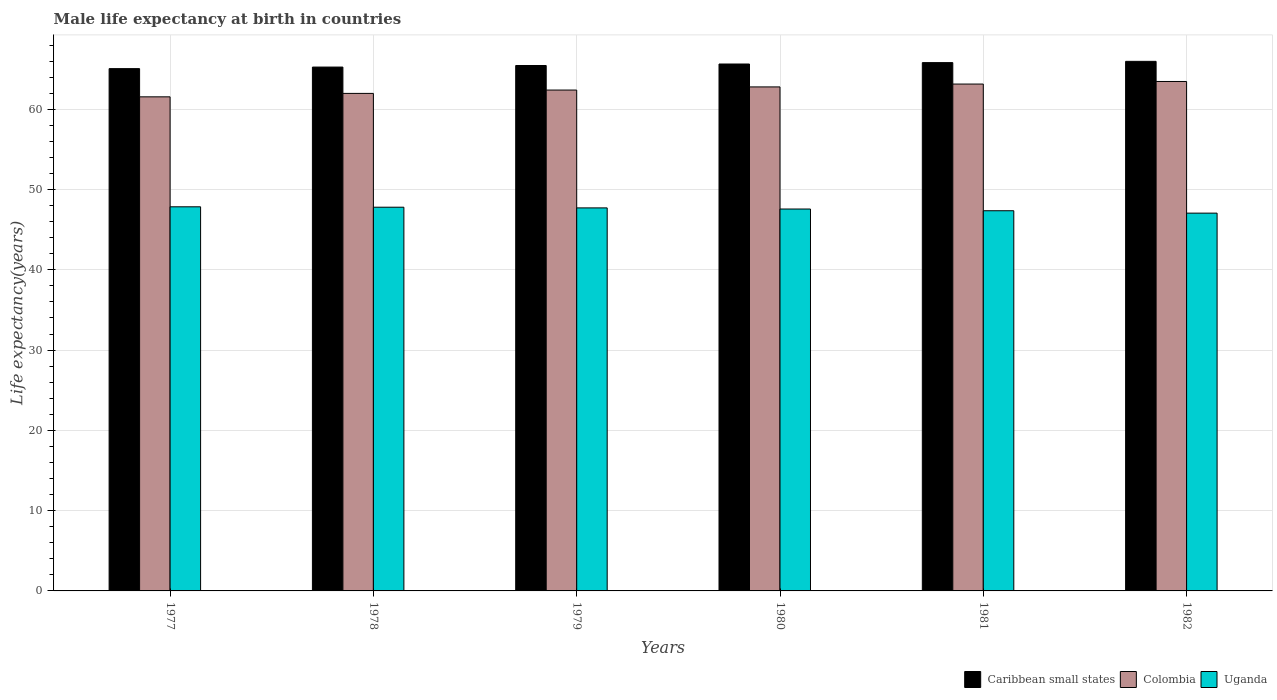How many groups of bars are there?
Provide a short and direct response. 6. Are the number of bars on each tick of the X-axis equal?
Your answer should be compact. Yes. How many bars are there on the 1st tick from the right?
Your response must be concise. 3. What is the label of the 1st group of bars from the left?
Make the answer very short. 1977. What is the male life expectancy at birth in Caribbean small states in 1979?
Offer a terse response. 65.45. Across all years, what is the maximum male life expectancy at birth in Uganda?
Provide a succinct answer. 47.85. Across all years, what is the minimum male life expectancy at birth in Uganda?
Provide a short and direct response. 47.06. In which year was the male life expectancy at birth in Colombia maximum?
Provide a succinct answer. 1982. What is the total male life expectancy at birth in Uganda in the graph?
Your answer should be compact. 285.36. What is the difference between the male life expectancy at birth in Uganda in 1978 and that in 1982?
Ensure brevity in your answer.  0.74. What is the difference between the male life expectancy at birth in Caribbean small states in 1977 and the male life expectancy at birth in Colombia in 1982?
Your response must be concise. 1.6. What is the average male life expectancy at birth in Colombia per year?
Ensure brevity in your answer.  62.55. In the year 1977, what is the difference between the male life expectancy at birth in Uganda and male life expectancy at birth in Caribbean small states?
Your answer should be compact. -17.21. What is the ratio of the male life expectancy at birth in Uganda in 1977 to that in 1980?
Give a very brief answer. 1.01. Is the difference between the male life expectancy at birth in Uganda in 1977 and 1981 greater than the difference between the male life expectancy at birth in Caribbean small states in 1977 and 1981?
Your answer should be very brief. Yes. What is the difference between the highest and the second highest male life expectancy at birth in Caribbean small states?
Your response must be concise. 0.16. What is the difference between the highest and the lowest male life expectancy at birth in Uganda?
Keep it short and to the point. 0.79. In how many years, is the male life expectancy at birth in Uganda greater than the average male life expectancy at birth in Uganda taken over all years?
Your answer should be compact. 4. Is the sum of the male life expectancy at birth in Caribbean small states in 1978 and 1982 greater than the maximum male life expectancy at birth in Uganda across all years?
Give a very brief answer. Yes. What does the 3rd bar from the left in 1982 represents?
Provide a succinct answer. Uganda. What does the 1st bar from the right in 1977 represents?
Offer a terse response. Uganda. How many bars are there?
Provide a succinct answer. 18. Are all the bars in the graph horizontal?
Your answer should be very brief. No. What is the difference between two consecutive major ticks on the Y-axis?
Make the answer very short. 10. Are the values on the major ticks of Y-axis written in scientific E-notation?
Give a very brief answer. No. How are the legend labels stacked?
Your response must be concise. Horizontal. What is the title of the graph?
Your answer should be very brief. Male life expectancy at birth in countries. Does "Serbia" appear as one of the legend labels in the graph?
Offer a very short reply. No. What is the label or title of the X-axis?
Ensure brevity in your answer.  Years. What is the label or title of the Y-axis?
Your response must be concise. Life expectancy(years). What is the Life expectancy(years) in Caribbean small states in 1977?
Your response must be concise. 65.06. What is the Life expectancy(years) of Colombia in 1977?
Your answer should be very brief. 61.55. What is the Life expectancy(years) in Uganda in 1977?
Provide a succinct answer. 47.85. What is the Life expectancy(years) of Caribbean small states in 1978?
Ensure brevity in your answer.  65.26. What is the Life expectancy(years) of Colombia in 1978?
Offer a very short reply. 61.98. What is the Life expectancy(years) of Uganda in 1978?
Ensure brevity in your answer.  47.8. What is the Life expectancy(years) in Caribbean small states in 1979?
Provide a succinct answer. 65.45. What is the Life expectancy(years) in Colombia in 1979?
Your answer should be compact. 62.39. What is the Life expectancy(years) of Uganda in 1979?
Offer a terse response. 47.71. What is the Life expectancy(years) of Caribbean small states in 1980?
Offer a very short reply. 65.64. What is the Life expectancy(years) of Colombia in 1980?
Your response must be concise. 62.78. What is the Life expectancy(years) of Uganda in 1980?
Provide a short and direct response. 47.57. What is the Life expectancy(years) in Caribbean small states in 1981?
Keep it short and to the point. 65.81. What is the Life expectancy(years) of Colombia in 1981?
Your answer should be compact. 63.14. What is the Life expectancy(years) in Uganda in 1981?
Give a very brief answer. 47.36. What is the Life expectancy(years) of Caribbean small states in 1982?
Keep it short and to the point. 65.97. What is the Life expectancy(years) in Colombia in 1982?
Give a very brief answer. 63.46. What is the Life expectancy(years) of Uganda in 1982?
Make the answer very short. 47.06. Across all years, what is the maximum Life expectancy(years) of Caribbean small states?
Your response must be concise. 65.97. Across all years, what is the maximum Life expectancy(years) of Colombia?
Keep it short and to the point. 63.46. Across all years, what is the maximum Life expectancy(years) in Uganda?
Keep it short and to the point. 47.85. Across all years, what is the minimum Life expectancy(years) of Caribbean small states?
Provide a succinct answer. 65.06. Across all years, what is the minimum Life expectancy(years) in Colombia?
Your answer should be compact. 61.55. Across all years, what is the minimum Life expectancy(years) of Uganda?
Offer a very short reply. 47.06. What is the total Life expectancy(years) of Caribbean small states in the graph?
Provide a succinct answer. 393.2. What is the total Life expectancy(years) of Colombia in the graph?
Give a very brief answer. 375.31. What is the total Life expectancy(years) in Uganda in the graph?
Ensure brevity in your answer.  285.36. What is the difference between the Life expectancy(years) of Caribbean small states in 1977 and that in 1978?
Your answer should be compact. -0.2. What is the difference between the Life expectancy(years) in Colombia in 1977 and that in 1978?
Provide a short and direct response. -0.43. What is the difference between the Life expectancy(years) of Uganda in 1977 and that in 1978?
Your answer should be very brief. 0.05. What is the difference between the Life expectancy(years) of Caribbean small states in 1977 and that in 1979?
Offer a very short reply. -0.39. What is the difference between the Life expectancy(years) in Colombia in 1977 and that in 1979?
Your response must be concise. -0.84. What is the difference between the Life expectancy(years) in Uganda in 1977 and that in 1979?
Your answer should be compact. 0.14. What is the difference between the Life expectancy(years) in Caribbean small states in 1977 and that in 1980?
Keep it short and to the point. -0.58. What is the difference between the Life expectancy(years) of Colombia in 1977 and that in 1980?
Offer a terse response. -1.24. What is the difference between the Life expectancy(years) of Uganda in 1977 and that in 1980?
Give a very brief answer. 0.28. What is the difference between the Life expectancy(years) of Caribbean small states in 1977 and that in 1981?
Give a very brief answer. -0.75. What is the difference between the Life expectancy(years) in Colombia in 1977 and that in 1981?
Your response must be concise. -1.59. What is the difference between the Life expectancy(years) in Uganda in 1977 and that in 1981?
Give a very brief answer. 0.49. What is the difference between the Life expectancy(years) in Caribbean small states in 1977 and that in 1982?
Provide a succinct answer. -0.91. What is the difference between the Life expectancy(years) of Colombia in 1977 and that in 1982?
Provide a succinct answer. -1.91. What is the difference between the Life expectancy(years) in Uganda in 1977 and that in 1982?
Give a very brief answer. 0.79. What is the difference between the Life expectancy(years) of Caribbean small states in 1978 and that in 1979?
Provide a short and direct response. -0.19. What is the difference between the Life expectancy(years) of Colombia in 1978 and that in 1979?
Provide a short and direct response. -0.42. What is the difference between the Life expectancy(years) of Uganda in 1978 and that in 1979?
Keep it short and to the point. 0.09. What is the difference between the Life expectancy(years) in Caribbean small states in 1978 and that in 1980?
Offer a very short reply. -0.38. What is the difference between the Life expectancy(years) of Colombia in 1978 and that in 1980?
Give a very brief answer. -0.81. What is the difference between the Life expectancy(years) of Uganda in 1978 and that in 1980?
Give a very brief answer. 0.23. What is the difference between the Life expectancy(years) in Caribbean small states in 1978 and that in 1981?
Give a very brief answer. -0.55. What is the difference between the Life expectancy(years) of Colombia in 1978 and that in 1981?
Provide a short and direct response. -1.16. What is the difference between the Life expectancy(years) in Uganda in 1978 and that in 1981?
Ensure brevity in your answer.  0.44. What is the difference between the Life expectancy(years) of Caribbean small states in 1978 and that in 1982?
Your answer should be compact. -0.71. What is the difference between the Life expectancy(years) of Colombia in 1978 and that in 1982?
Your answer should be compact. -1.49. What is the difference between the Life expectancy(years) in Uganda in 1978 and that in 1982?
Offer a very short reply. 0.74. What is the difference between the Life expectancy(years) of Caribbean small states in 1979 and that in 1980?
Make the answer very short. -0.19. What is the difference between the Life expectancy(years) of Colombia in 1979 and that in 1980?
Make the answer very short. -0.39. What is the difference between the Life expectancy(years) in Uganda in 1979 and that in 1980?
Keep it short and to the point. 0.14. What is the difference between the Life expectancy(years) of Caribbean small states in 1979 and that in 1981?
Ensure brevity in your answer.  -0.36. What is the difference between the Life expectancy(years) in Colombia in 1979 and that in 1981?
Your answer should be compact. -0.75. What is the difference between the Life expectancy(years) in Uganda in 1979 and that in 1981?
Offer a terse response. 0.35. What is the difference between the Life expectancy(years) of Caribbean small states in 1979 and that in 1982?
Offer a very short reply. -0.52. What is the difference between the Life expectancy(years) in Colombia in 1979 and that in 1982?
Give a very brief answer. -1.07. What is the difference between the Life expectancy(years) of Uganda in 1979 and that in 1982?
Your response must be concise. 0.65. What is the difference between the Life expectancy(years) of Caribbean small states in 1980 and that in 1981?
Your response must be concise. -0.17. What is the difference between the Life expectancy(years) of Colombia in 1980 and that in 1981?
Your answer should be very brief. -0.36. What is the difference between the Life expectancy(years) in Uganda in 1980 and that in 1981?
Your answer should be compact. 0.21. What is the difference between the Life expectancy(years) in Caribbean small states in 1980 and that in 1982?
Ensure brevity in your answer.  -0.33. What is the difference between the Life expectancy(years) in Colombia in 1980 and that in 1982?
Ensure brevity in your answer.  -0.68. What is the difference between the Life expectancy(years) in Uganda in 1980 and that in 1982?
Keep it short and to the point. 0.51. What is the difference between the Life expectancy(years) of Caribbean small states in 1981 and that in 1982?
Give a very brief answer. -0.16. What is the difference between the Life expectancy(years) in Colombia in 1981 and that in 1982?
Your response must be concise. -0.32. What is the difference between the Life expectancy(years) of Uganda in 1981 and that in 1982?
Your answer should be compact. 0.3. What is the difference between the Life expectancy(years) in Caribbean small states in 1977 and the Life expectancy(years) in Colombia in 1978?
Provide a short and direct response. 3.09. What is the difference between the Life expectancy(years) in Caribbean small states in 1977 and the Life expectancy(years) in Uganda in 1978?
Keep it short and to the point. 17.26. What is the difference between the Life expectancy(years) in Colombia in 1977 and the Life expectancy(years) in Uganda in 1978?
Your answer should be very brief. 13.75. What is the difference between the Life expectancy(years) of Caribbean small states in 1977 and the Life expectancy(years) of Colombia in 1979?
Make the answer very short. 2.67. What is the difference between the Life expectancy(years) of Caribbean small states in 1977 and the Life expectancy(years) of Uganda in 1979?
Make the answer very short. 17.35. What is the difference between the Life expectancy(years) of Colombia in 1977 and the Life expectancy(years) of Uganda in 1979?
Make the answer very short. 13.84. What is the difference between the Life expectancy(years) of Caribbean small states in 1977 and the Life expectancy(years) of Colombia in 1980?
Make the answer very short. 2.28. What is the difference between the Life expectancy(years) in Caribbean small states in 1977 and the Life expectancy(years) in Uganda in 1980?
Your answer should be compact. 17.49. What is the difference between the Life expectancy(years) in Colombia in 1977 and the Life expectancy(years) in Uganda in 1980?
Offer a very short reply. 13.97. What is the difference between the Life expectancy(years) of Caribbean small states in 1977 and the Life expectancy(years) of Colombia in 1981?
Give a very brief answer. 1.92. What is the difference between the Life expectancy(years) of Caribbean small states in 1977 and the Life expectancy(years) of Uganda in 1981?
Offer a very short reply. 17.7. What is the difference between the Life expectancy(years) in Colombia in 1977 and the Life expectancy(years) in Uganda in 1981?
Your response must be concise. 14.19. What is the difference between the Life expectancy(years) in Caribbean small states in 1977 and the Life expectancy(years) in Colombia in 1982?
Ensure brevity in your answer.  1.6. What is the difference between the Life expectancy(years) of Caribbean small states in 1977 and the Life expectancy(years) of Uganda in 1982?
Offer a terse response. 18. What is the difference between the Life expectancy(years) of Colombia in 1977 and the Life expectancy(years) of Uganda in 1982?
Provide a succinct answer. 14.49. What is the difference between the Life expectancy(years) in Caribbean small states in 1978 and the Life expectancy(years) in Colombia in 1979?
Your response must be concise. 2.86. What is the difference between the Life expectancy(years) in Caribbean small states in 1978 and the Life expectancy(years) in Uganda in 1979?
Ensure brevity in your answer.  17.54. What is the difference between the Life expectancy(years) of Colombia in 1978 and the Life expectancy(years) of Uganda in 1979?
Provide a succinct answer. 14.26. What is the difference between the Life expectancy(years) of Caribbean small states in 1978 and the Life expectancy(years) of Colombia in 1980?
Offer a terse response. 2.47. What is the difference between the Life expectancy(years) of Caribbean small states in 1978 and the Life expectancy(years) of Uganda in 1980?
Make the answer very short. 17.68. What is the difference between the Life expectancy(years) in Colombia in 1978 and the Life expectancy(years) in Uganda in 1980?
Offer a very short reply. 14.4. What is the difference between the Life expectancy(years) of Caribbean small states in 1978 and the Life expectancy(years) of Colombia in 1981?
Offer a very short reply. 2.12. What is the difference between the Life expectancy(years) in Caribbean small states in 1978 and the Life expectancy(years) in Uganda in 1981?
Offer a terse response. 17.9. What is the difference between the Life expectancy(years) in Colombia in 1978 and the Life expectancy(years) in Uganda in 1981?
Your answer should be very brief. 14.62. What is the difference between the Life expectancy(years) in Caribbean small states in 1978 and the Life expectancy(years) in Colombia in 1982?
Your answer should be very brief. 1.8. What is the difference between the Life expectancy(years) in Caribbean small states in 1978 and the Life expectancy(years) in Uganda in 1982?
Offer a terse response. 18.2. What is the difference between the Life expectancy(years) in Colombia in 1978 and the Life expectancy(years) in Uganda in 1982?
Your answer should be very brief. 14.91. What is the difference between the Life expectancy(years) of Caribbean small states in 1979 and the Life expectancy(years) of Colombia in 1980?
Ensure brevity in your answer.  2.67. What is the difference between the Life expectancy(years) in Caribbean small states in 1979 and the Life expectancy(years) in Uganda in 1980?
Ensure brevity in your answer.  17.88. What is the difference between the Life expectancy(years) of Colombia in 1979 and the Life expectancy(years) of Uganda in 1980?
Your response must be concise. 14.82. What is the difference between the Life expectancy(years) of Caribbean small states in 1979 and the Life expectancy(years) of Colombia in 1981?
Give a very brief answer. 2.31. What is the difference between the Life expectancy(years) in Caribbean small states in 1979 and the Life expectancy(years) in Uganda in 1981?
Make the answer very short. 18.09. What is the difference between the Life expectancy(years) of Colombia in 1979 and the Life expectancy(years) of Uganda in 1981?
Ensure brevity in your answer.  15.03. What is the difference between the Life expectancy(years) in Caribbean small states in 1979 and the Life expectancy(years) in Colombia in 1982?
Make the answer very short. 1.99. What is the difference between the Life expectancy(years) of Caribbean small states in 1979 and the Life expectancy(years) of Uganda in 1982?
Your answer should be compact. 18.39. What is the difference between the Life expectancy(years) in Colombia in 1979 and the Life expectancy(years) in Uganda in 1982?
Make the answer very short. 15.33. What is the difference between the Life expectancy(years) of Caribbean small states in 1980 and the Life expectancy(years) of Colombia in 1981?
Give a very brief answer. 2.5. What is the difference between the Life expectancy(years) in Caribbean small states in 1980 and the Life expectancy(years) in Uganda in 1981?
Ensure brevity in your answer.  18.28. What is the difference between the Life expectancy(years) of Colombia in 1980 and the Life expectancy(years) of Uganda in 1981?
Provide a short and direct response. 15.43. What is the difference between the Life expectancy(years) of Caribbean small states in 1980 and the Life expectancy(years) of Colombia in 1982?
Your answer should be compact. 2.18. What is the difference between the Life expectancy(years) of Caribbean small states in 1980 and the Life expectancy(years) of Uganda in 1982?
Provide a short and direct response. 18.58. What is the difference between the Life expectancy(years) of Colombia in 1980 and the Life expectancy(years) of Uganda in 1982?
Keep it short and to the point. 15.72. What is the difference between the Life expectancy(years) of Caribbean small states in 1981 and the Life expectancy(years) of Colombia in 1982?
Your answer should be compact. 2.35. What is the difference between the Life expectancy(years) in Caribbean small states in 1981 and the Life expectancy(years) in Uganda in 1982?
Make the answer very short. 18.75. What is the difference between the Life expectancy(years) of Colombia in 1981 and the Life expectancy(years) of Uganda in 1982?
Offer a very short reply. 16.08. What is the average Life expectancy(years) in Caribbean small states per year?
Provide a short and direct response. 65.53. What is the average Life expectancy(years) of Colombia per year?
Make the answer very short. 62.55. What is the average Life expectancy(years) in Uganda per year?
Keep it short and to the point. 47.56. In the year 1977, what is the difference between the Life expectancy(years) in Caribbean small states and Life expectancy(years) in Colombia?
Your answer should be compact. 3.51. In the year 1977, what is the difference between the Life expectancy(years) of Caribbean small states and Life expectancy(years) of Uganda?
Give a very brief answer. 17.21. In the year 1977, what is the difference between the Life expectancy(years) of Colombia and Life expectancy(years) of Uganda?
Your response must be concise. 13.7. In the year 1978, what is the difference between the Life expectancy(years) in Caribbean small states and Life expectancy(years) in Colombia?
Your response must be concise. 3.28. In the year 1978, what is the difference between the Life expectancy(years) of Caribbean small states and Life expectancy(years) of Uganda?
Provide a short and direct response. 17.46. In the year 1978, what is the difference between the Life expectancy(years) of Colombia and Life expectancy(years) of Uganda?
Provide a succinct answer. 14.18. In the year 1979, what is the difference between the Life expectancy(years) in Caribbean small states and Life expectancy(years) in Colombia?
Provide a short and direct response. 3.06. In the year 1979, what is the difference between the Life expectancy(years) in Caribbean small states and Life expectancy(years) in Uganda?
Offer a very short reply. 17.74. In the year 1979, what is the difference between the Life expectancy(years) in Colombia and Life expectancy(years) in Uganda?
Your response must be concise. 14.68. In the year 1980, what is the difference between the Life expectancy(years) of Caribbean small states and Life expectancy(years) of Colombia?
Your response must be concise. 2.85. In the year 1980, what is the difference between the Life expectancy(years) in Caribbean small states and Life expectancy(years) in Uganda?
Offer a very short reply. 18.07. In the year 1980, what is the difference between the Life expectancy(years) in Colombia and Life expectancy(years) in Uganda?
Make the answer very short. 15.21. In the year 1981, what is the difference between the Life expectancy(years) of Caribbean small states and Life expectancy(years) of Colombia?
Provide a succinct answer. 2.67. In the year 1981, what is the difference between the Life expectancy(years) in Caribbean small states and Life expectancy(years) in Uganda?
Make the answer very short. 18.45. In the year 1981, what is the difference between the Life expectancy(years) of Colombia and Life expectancy(years) of Uganda?
Offer a terse response. 15.78. In the year 1982, what is the difference between the Life expectancy(years) in Caribbean small states and Life expectancy(years) in Colombia?
Provide a short and direct response. 2.51. In the year 1982, what is the difference between the Life expectancy(years) in Caribbean small states and Life expectancy(years) in Uganda?
Ensure brevity in your answer.  18.91. What is the ratio of the Life expectancy(years) of Caribbean small states in 1977 to that in 1978?
Offer a terse response. 1. What is the ratio of the Life expectancy(years) of Colombia in 1977 to that in 1978?
Offer a terse response. 0.99. What is the ratio of the Life expectancy(years) of Caribbean small states in 1977 to that in 1979?
Offer a very short reply. 0.99. What is the ratio of the Life expectancy(years) of Colombia in 1977 to that in 1979?
Provide a succinct answer. 0.99. What is the ratio of the Life expectancy(years) in Colombia in 1977 to that in 1980?
Ensure brevity in your answer.  0.98. What is the ratio of the Life expectancy(years) of Uganda in 1977 to that in 1980?
Ensure brevity in your answer.  1.01. What is the ratio of the Life expectancy(years) of Colombia in 1977 to that in 1981?
Provide a succinct answer. 0.97. What is the ratio of the Life expectancy(years) of Uganda in 1977 to that in 1981?
Offer a terse response. 1.01. What is the ratio of the Life expectancy(years) in Caribbean small states in 1977 to that in 1982?
Give a very brief answer. 0.99. What is the ratio of the Life expectancy(years) of Colombia in 1977 to that in 1982?
Your answer should be very brief. 0.97. What is the ratio of the Life expectancy(years) in Uganda in 1977 to that in 1982?
Keep it short and to the point. 1.02. What is the ratio of the Life expectancy(years) of Uganda in 1978 to that in 1979?
Give a very brief answer. 1. What is the ratio of the Life expectancy(years) of Colombia in 1978 to that in 1980?
Ensure brevity in your answer.  0.99. What is the ratio of the Life expectancy(years) in Uganda in 1978 to that in 1980?
Provide a succinct answer. 1. What is the ratio of the Life expectancy(years) of Colombia in 1978 to that in 1981?
Your answer should be compact. 0.98. What is the ratio of the Life expectancy(years) in Uganda in 1978 to that in 1981?
Offer a terse response. 1.01. What is the ratio of the Life expectancy(years) in Caribbean small states in 1978 to that in 1982?
Ensure brevity in your answer.  0.99. What is the ratio of the Life expectancy(years) in Colombia in 1978 to that in 1982?
Provide a short and direct response. 0.98. What is the ratio of the Life expectancy(years) in Uganda in 1978 to that in 1982?
Offer a very short reply. 1.02. What is the ratio of the Life expectancy(years) of Caribbean small states in 1979 to that in 1980?
Offer a very short reply. 1. What is the ratio of the Life expectancy(years) in Uganda in 1979 to that in 1980?
Your answer should be compact. 1. What is the ratio of the Life expectancy(years) of Caribbean small states in 1979 to that in 1981?
Provide a succinct answer. 0.99. What is the ratio of the Life expectancy(years) in Uganda in 1979 to that in 1981?
Your answer should be very brief. 1.01. What is the ratio of the Life expectancy(years) in Caribbean small states in 1979 to that in 1982?
Provide a succinct answer. 0.99. What is the ratio of the Life expectancy(years) of Colombia in 1979 to that in 1982?
Give a very brief answer. 0.98. What is the ratio of the Life expectancy(years) of Uganda in 1979 to that in 1982?
Provide a short and direct response. 1.01. What is the ratio of the Life expectancy(years) in Caribbean small states in 1980 to that in 1982?
Provide a succinct answer. 0.99. What is the ratio of the Life expectancy(years) in Colombia in 1980 to that in 1982?
Keep it short and to the point. 0.99. What is the ratio of the Life expectancy(years) of Uganda in 1980 to that in 1982?
Provide a short and direct response. 1.01. What is the ratio of the Life expectancy(years) in Colombia in 1981 to that in 1982?
Your response must be concise. 0.99. What is the ratio of the Life expectancy(years) in Uganda in 1981 to that in 1982?
Your answer should be very brief. 1.01. What is the difference between the highest and the second highest Life expectancy(years) in Caribbean small states?
Your answer should be very brief. 0.16. What is the difference between the highest and the second highest Life expectancy(years) of Colombia?
Your response must be concise. 0.32. What is the difference between the highest and the second highest Life expectancy(years) in Uganda?
Provide a succinct answer. 0.05. What is the difference between the highest and the lowest Life expectancy(years) in Caribbean small states?
Keep it short and to the point. 0.91. What is the difference between the highest and the lowest Life expectancy(years) in Colombia?
Your answer should be very brief. 1.91. What is the difference between the highest and the lowest Life expectancy(years) in Uganda?
Your response must be concise. 0.79. 